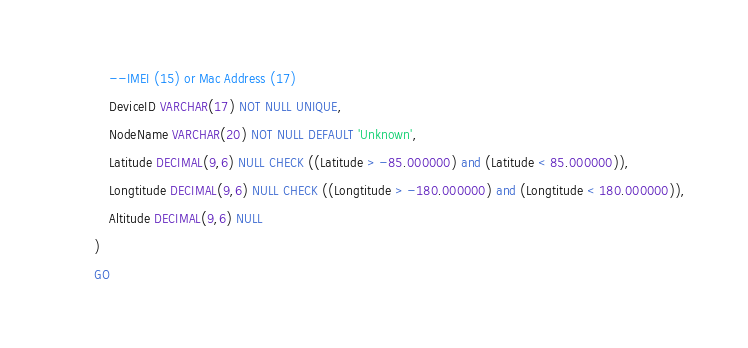<code> <loc_0><loc_0><loc_500><loc_500><_SQL_>	--IMEI (15) or Mac Address (17)
	DeviceID VARCHAR(17) NOT NULL UNIQUE,
	NodeName VARCHAR(20) NOT NULL DEFAULT 'Unknown',
	Latitude DECIMAL(9,6) NULL CHECK ((Latitude > -85.000000) and (Latitude < 85.000000)),
	Longtitude DECIMAL(9,6) NULL CHECK ((Longtitude > -180.000000) and (Longtitude < 180.000000)),
	Altitude DECIMAL(9,6) NULL
)
GO</code> 